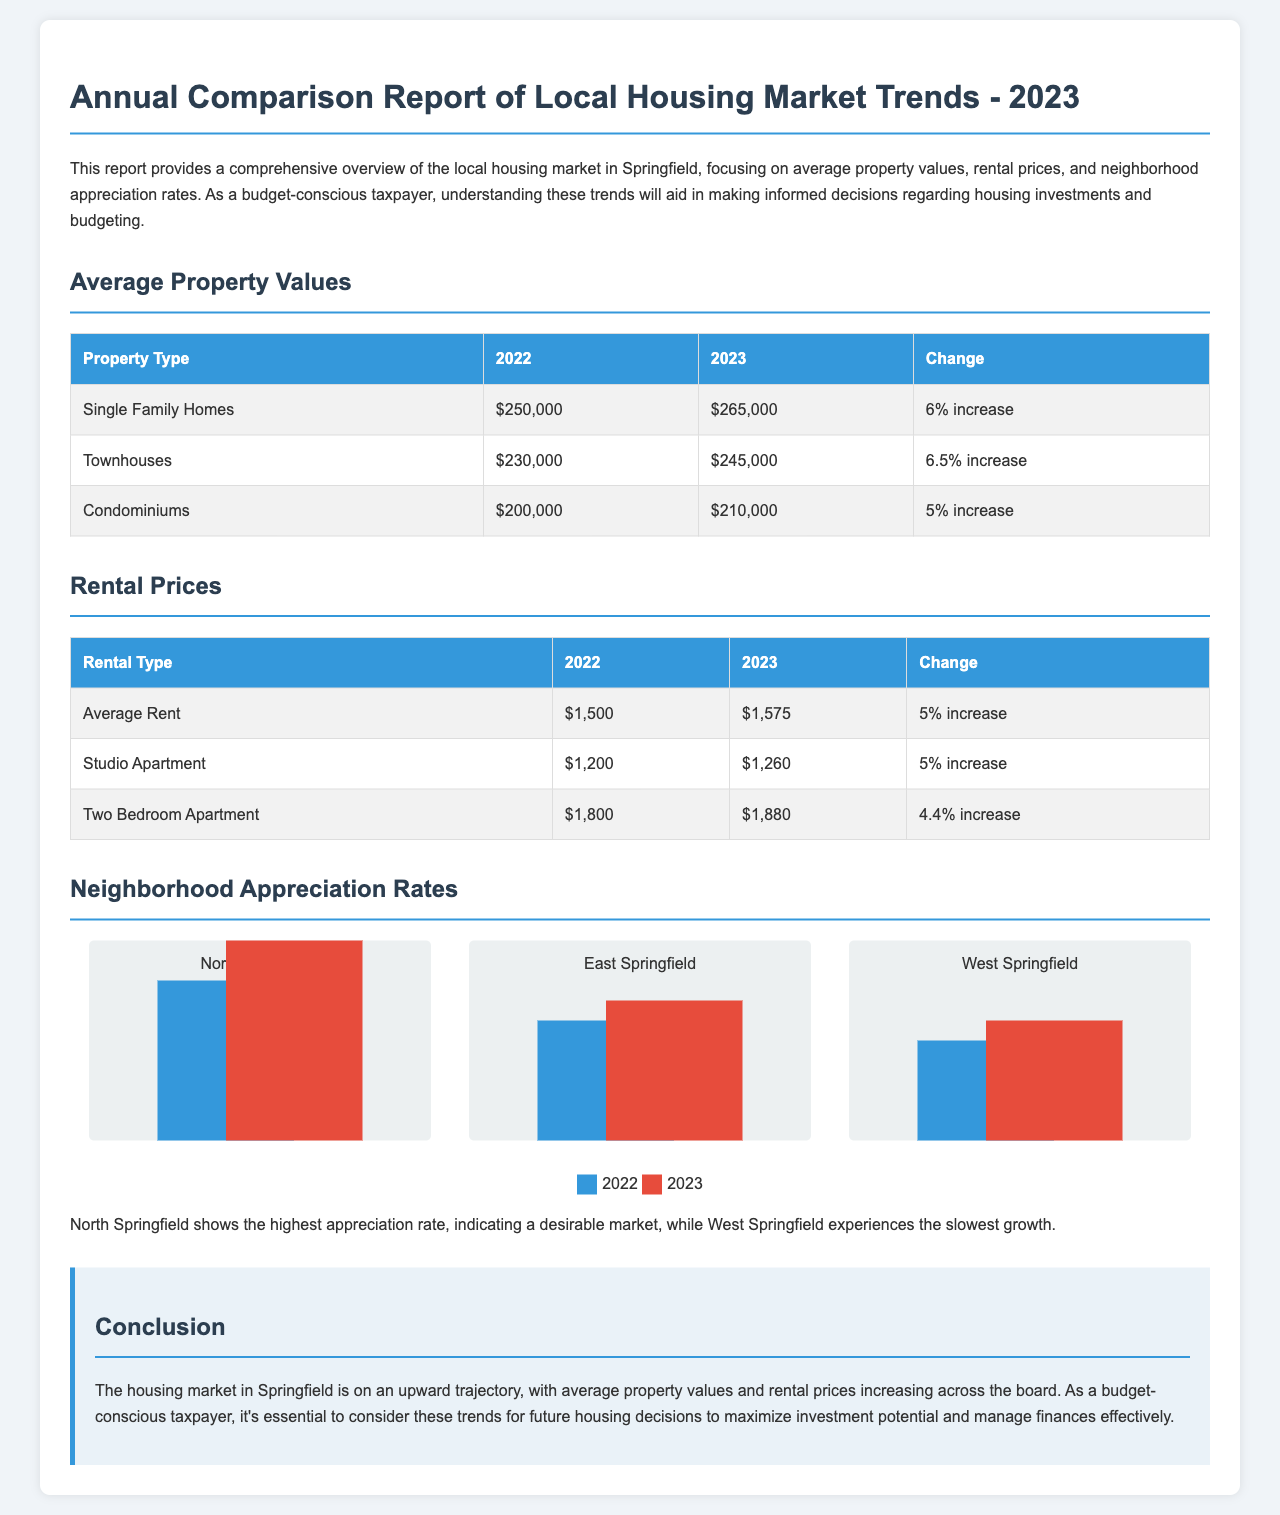What is the average property value for single family homes in 2023? The average property value for single family homes in 2023 is provided in the report, specifically in the "Average Property Values" section.
Answer: $265,000 What was the rental price for a two bedroom apartment in 2022? The rental price for a two bedroom apartment in 2022 is specified in the "Rental Prices" section of the report.
Answer: $1,800 Which neighborhood had the highest appreciation rate in 2023? The report indicates that North Springfield shows the highest appreciation rate in comparison to other neighborhoods.
Answer: North Springfield What was the percentage increase in townhouse values from 2022 to 2023? To find the percentage increase in townhouse values, compare the values provided for 2022 and 2023 in the "Average Property Values" table.
Answer: 6.5% increase What is the average rent in 2023? The average rent figure for 2023 can be found in the "Rental Prices" table of the report.
Answer: $1,575 What percentage increase did rental prices experience in 2023 compared to 2022? By examining the "Rental Prices" section, the report indicates the percentage increase for average rent.
Answer: 5% increase What color represents the 2023 bar in the neighborhood appreciation rates chart? The color coding for the bars in the neighborhood appreciation rates chart is explained in the document.
Answer: Red How much did condominium values increase in 2023? The increase in condominium values can be identified in the "Average Property Values" table.
Answer: $10,000 What type of document is this? The document provides an overview of housing market trends, specifically focused on pricing and appreciation in a local context.
Answer: Annual Comparison Report 